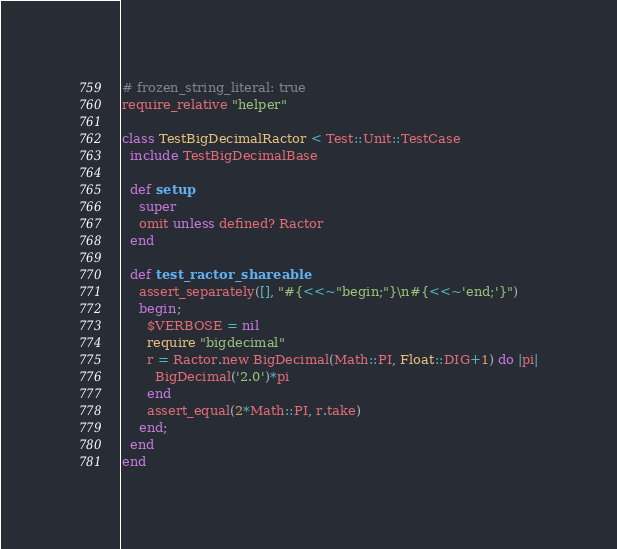Convert code to text. <code><loc_0><loc_0><loc_500><loc_500><_Ruby_># frozen_string_literal: true
require_relative "helper"

class TestBigDecimalRactor < Test::Unit::TestCase
  include TestBigDecimalBase

  def setup
    super
    omit unless defined? Ractor
  end

  def test_ractor_shareable
    assert_separately([], "#{<<~"begin;"}\n#{<<~'end;'}")
    begin;
      $VERBOSE = nil
      require "bigdecimal"
      r = Ractor.new BigDecimal(Math::PI, Float::DIG+1) do |pi|
        BigDecimal('2.0')*pi
      end
      assert_equal(2*Math::PI, r.take)
    end;
  end
end
</code> 